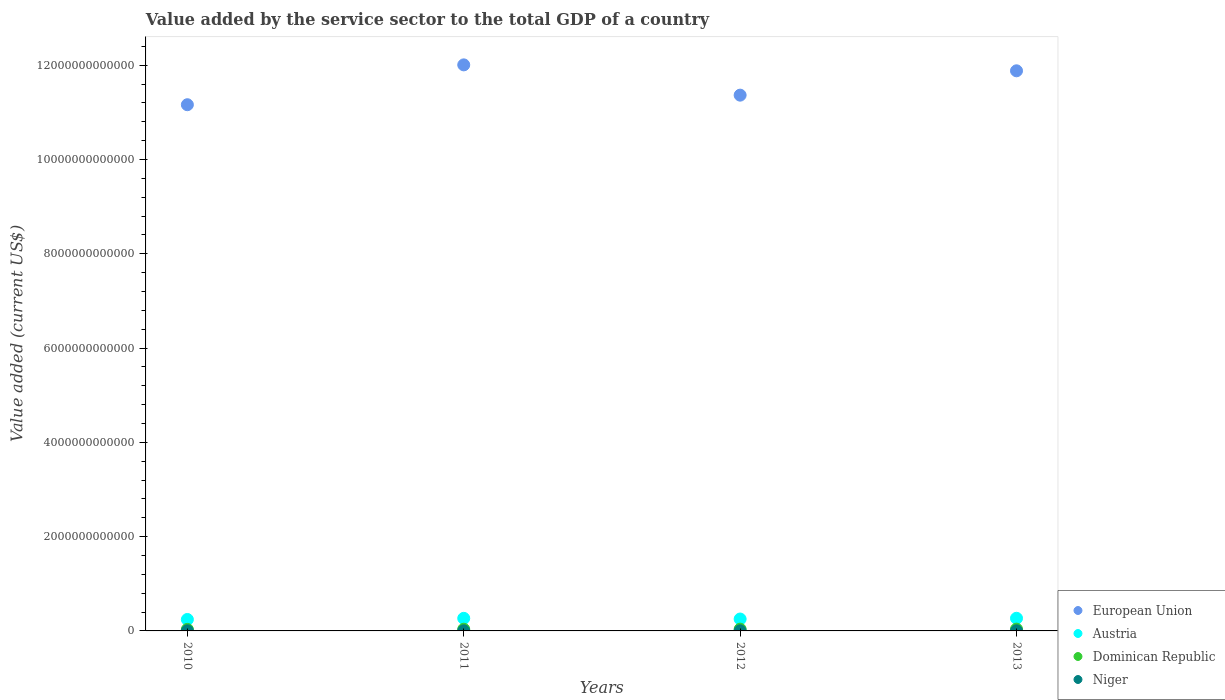How many different coloured dotlines are there?
Your answer should be very brief. 4. What is the value added by the service sector to the total GDP in Niger in 2012?
Your answer should be very brief. 2.84e+09. Across all years, what is the maximum value added by the service sector to the total GDP in Dominican Republic?
Provide a short and direct response. 3.82e+1. Across all years, what is the minimum value added by the service sector to the total GDP in European Union?
Ensure brevity in your answer.  1.12e+13. What is the total value added by the service sector to the total GDP in Dominican Republic in the graph?
Offer a very short reply. 1.44e+11. What is the difference between the value added by the service sector to the total GDP in Dominican Republic in 2011 and that in 2013?
Give a very brief answer. -2.26e+09. What is the difference between the value added by the service sector to the total GDP in European Union in 2012 and the value added by the service sector to the total GDP in Niger in 2010?
Your answer should be very brief. 1.14e+13. What is the average value added by the service sector to the total GDP in Dominican Republic per year?
Your answer should be compact. 3.61e+1. In the year 2010, what is the difference between the value added by the service sector to the total GDP in Austria and value added by the service sector to the total GDP in Dominican Republic?
Ensure brevity in your answer.  2.10e+11. In how many years, is the value added by the service sector to the total GDP in Austria greater than 7200000000000 US$?
Offer a terse response. 0. What is the ratio of the value added by the service sector to the total GDP in Niger in 2010 to that in 2011?
Provide a short and direct response. 0.85. Is the value added by the service sector to the total GDP in Dominican Republic in 2012 less than that in 2013?
Provide a short and direct response. Yes. What is the difference between the highest and the second highest value added by the service sector to the total GDP in European Union?
Give a very brief answer. 1.26e+11. What is the difference between the highest and the lowest value added by the service sector to the total GDP in Dominican Republic?
Ensure brevity in your answer.  5.58e+09. In how many years, is the value added by the service sector to the total GDP in Dominican Republic greater than the average value added by the service sector to the total GDP in Dominican Republic taken over all years?
Give a very brief answer. 2. Is it the case that in every year, the sum of the value added by the service sector to the total GDP in European Union and value added by the service sector to the total GDP in Austria  is greater than the sum of value added by the service sector to the total GDP in Niger and value added by the service sector to the total GDP in Dominican Republic?
Provide a short and direct response. Yes. Does the value added by the service sector to the total GDP in Dominican Republic monotonically increase over the years?
Provide a succinct answer. Yes. How many years are there in the graph?
Your response must be concise. 4. What is the difference between two consecutive major ticks on the Y-axis?
Keep it short and to the point. 2.00e+12. Does the graph contain grids?
Provide a short and direct response. No. Where does the legend appear in the graph?
Give a very brief answer. Bottom right. How are the legend labels stacked?
Your answer should be compact. Vertical. What is the title of the graph?
Provide a short and direct response. Value added by the service sector to the total GDP of a country. What is the label or title of the X-axis?
Your answer should be very brief. Years. What is the label or title of the Y-axis?
Make the answer very short. Value added (current US$). What is the Value added (current US$) of European Union in 2010?
Make the answer very short. 1.12e+13. What is the Value added (current US$) in Austria in 2010?
Provide a short and direct response. 2.43e+11. What is the Value added (current US$) in Dominican Republic in 2010?
Provide a succinct answer. 3.26e+1. What is the Value added (current US$) in Niger in 2010?
Provide a succinct answer. 2.49e+09. What is the Value added (current US$) of European Union in 2011?
Offer a very short reply. 1.20e+13. What is the Value added (current US$) in Austria in 2011?
Offer a very short reply. 2.67e+11. What is the Value added (current US$) in Dominican Republic in 2011?
Keep it short and to the point. 3.59e+1. What is the Value added (current US$) in Niger in 2011?
Ensure brevity in your answer.  2.93e+09. What is the Value added (current US$) of European Union in 2012?
Keep it short and to the point. 1.14e+13. What is the Value added (current US$) of Austria in 2012?
Offer a terse response. 2.52e+11. What is the Value added (current US$) in Dominican Republic in 2012?
Make the answer very short. 3.77e+1. What is the Value added (current US$) of Niger in 2012?
Provide a short and direct response. 2.84e+09. What is the Value added (current US$) in European Union in 2013?
Offer a terse response. 1.19e+13. What is the Value added (current US$) of Austria in 2013?
Your response must be concise. 2.68e+11. What is the Value added (current US$) of Dominican Republic in 2013?
Your response must be concise. 3.82e+1. What is the Value added (current US$) of Niger in 2013?
Provide a short and direct response. 3.25e+09. Across all years, what is the maximum Value added (current US$) in European Union?
Ensure brevity in your answer.  1.20e+13. Across all years, what is the maximum Value added (current US$) in Austria?
Ensure brevity in your answer.  2.68e+11. Across all years, what is the maximum Value added (current US$) of Dominican Republic?
Keep it short and to the point. 3.82e+1. Across all years, what is the maximum Value added (current US$) of Niger?
Your response must be concise. 3.25e+09. Across all years, what is the minimum Value added (current US$) of European Union?
Provide a short and direct response. 1.12e+13. Across all years, what is the minimum Value added (current US$) in Austria?
Offer a very short reply. 2.43e+11. Across all years, what is the minimum Value added (current US$) in Dominican Republic?
Keep it short and to the point. 3.26e+1. Across all years, what is the minimum Value added (current US$) in Niger?
Offer a terse response. 2.49e+09. What is the total Value added (current US$) in European Union in the graph?
Keep it short and to the point. 4.64e+13. What is the total Value added (current US$) in Austria in the graph?
Offer a very short reply. 1.03e+12. What is the total Value added (current US$) of Dominican Republic in the graph?
Ensure brevity in your answer.  1.44e+11. What is the total Value added (current US$) in Niger in the graph?
Offer a terse response. 1.15e+1. What is the difference between the Value added (current US$) in European Union in 2010 and that in 2011?
Keep it short and to the point. -8.45e+11. What is the difference between the Value added (current US$) of Austria in 2010 and that in 2011?
Offer a terse response. -2.41e+1. What is the difference between the Value added (current US$) in Dominican Republic in 2010 and that in 2011?
Make the answer very short. -3.31e+09. What is the difference between the Value added (current US$) of Niger in 2010 and that in 2011?
Provide a succinct answer. -4.40e+08. What is the difference between the Value added (current US$) of European Union in 2010 and that in 2012?
Provide a short and direct response. -2.03e+11. What is the difference between the Value added (current US$) in Austria in 2010 and that in 2012?
Give a very brief answer. -9.58e+09. What is the difference between the Value added (current US$) of Dominican Republic in 2010 and that in 2012?
Ensure brevity in your answer.  -5.04e+09. What is the difference between the Value added (current US$) of Niger in 2010 and that in 2012?
Provide a short and direct response. -3.49e+08. What is the difference between the Value added (current US$) of European Union in 2010 and that in 2013?
Offer a terse response. -7.19e+11. What is the difference between the Value added (current US$) of Austria in 2010 and that in 2013?
Make the answer very short. -2.56e+1. What is the difference between the Value added (current US$) of Dominican Republic in 2010 and that in 2013?
Your answer should be compact. -5.58e+09. What is the difference between the Value added (current US$) of Niger in 2010 and that in 2013?
Offer a very short reply. -7.64e+08. What is the difference between the Value added (current US$) of European Union in 2011 and that in 2012?
Your answer should be compact. 6.42e+11. What is the difference between the Value added (current US$) in Austria in 2011 and that in 2012?
Your answer should be very brief. 1.45e+1. What is the difference between the Value added (current US$) of Dominican Republic in 2011 and that in 2012?
Provide a succinct answer. -1.73e+09. What is the difference between the Value added (current US$) of Niger in 2011 and that in 2012?
Ensure brevity in your answer.  9.05e+07. What is the difference between the Value added (current US$) in European Union in 2011 and that in 2013?
Your response must be concise. 1.26e+11. What is the difference between the Value added (current US$) in Austria in 2011 and that in 2013?
Your response must be concise. -1.50e+09. What is the difference between the Value added (current US$) in Dominican Republic in 2011 and that in 2013?
Give a very brief answer. -2.26e+09. What is the difference between the Value added (current US$) of Niger in 2011 and that in 2013?
Give a very brief answer. -3.25e+08. What is the difference between the Value added (current US$) of European Union in 2012 and that in 2013?
Provide a short and direct response. -5.16e+11. What is the difference between the Value added (current US$) in Austria in 2012 and that in 2013?
Ensure brevity in your answer.  -1.60e+1. What is the difference between the Value added (current US$) of Dominican Republic in 2012 and that in 2013?
Your response must be concise. -5.32e+08. What is the difference between the Value added (current US$) in Niger in 2012 and that in 2013?
Offer a very short reply. -4.15e+08. What is the difference between the Value added (current US$) of European Union in 2010 and the Value added (current US$) of Austria in 2011?
Your answer should be very brief. 1.09e+13. What is the difference between the Value added (current US$) in European Union in 2010 and the Value added (current US$) in Dominican Republic in 2011?
Your answer should be compact. 1.11e+13. What is the difference between the Value added (current US$) of European Union in 2010 and the Value added (current US$) of Niger in 2011?
Provide a succinct answer. 1.12e+13. What is the difference between the Value added (current US$) in Austria in 2010 and the Value added (current US$) in Dominican Republic in 2011?
Your response must be concise. 2.07e+11. What is the difference between the Value added (current US$) of Austria in 2010 and the Value added (current US$) of Niger in 2011?
Make the answer very short. 2.40e+11. What is the difference between the Value added (current US$) of Dominican Republic in 2010 and the Value added (current US$) of Niger in 2011?
Your response must be concise. 2.97e+1. What is the difference between the Value added (current US$) of European Union in 2010 and the Value added (current US$) of Austria in 2012?
Ensure brevity in your answer.  1.09e+13. What is the difference between the Value added (current US$) of European Union in 2010 and the Value added (current US$) of Dominican Republic in 2012?
Give a very brief answer. 1.11e+13. What is the difference between the Value added (current US$) in European Union in 2010 and the Value added (current US$) in Niger in 2012?
Your answer should be compact. 1.12e+13. What is the difference between the Value added (current US$) of Austria in 2010 and the Value added (current US$) of Dominican Republic in 2012?
Offer a very short reply. 2.05e+11. What is the difference between the Value added (current US$) in Austria in 2010 and the Value added (current US$) in Niger in 2012?
Make the answer very short. 2.40e+11. What is the difference between the Value added (current US$) in Dominican Republic in 2010 and the Value added (current US$) in Niger in 2012?
Offer a very short reply. 2.98e+1. What is the difference between the Value added (current US$) in European Union in 2010 and the Value added (current US$) in Austria in 2013?
Offer a terse response. 1.09e+13. What is the difference between the Value added (current US$) of European Union in 2010 and the Value added (current US$) of Dominican Republic in 2013?
Your answer should be very brief. 1.11e+13. What is the difference between the Value added (current US$) of European Union in 2010 and the Value added (current US$) of Niger in 2013?
Your answer should be very brief. 1.12e+13. What is the difference between the Value added (current US$) in Austria in 2010 and the Value added (current US$) in Dominican Republic in 2013?
Your answer should be compact. 2.05e+11. What is the difference between the Value added (current US$) in Austria in 2010 and the Value added (current US$) in Niger in 2013?
Offer a very short reply. 2.40e+11. What is the difference between the Value added (current US$) of Dominican Republic in 2010 and the Value added (current US$) of Niger in 2013?
Your answer should be compact. 2.94e+1. What is the difference between the Value added (current US$) of European Union in 2011 and the Value added (current US$) of Austria in 2012?
Provide a short and direct response. 1.18e+13. What is the difference between the Value added (current US$) of European Union in 2011 and the Value added (current US$) of Dominican Republic in 2012?
Provide a short and direct response. 1.20e+13. What is the difference between the Value added (current US$) of European Union in 2011 and the Value added (current US$) of Niger in 2012?
Keep it short and to the point. 1.20e+13. What is the difference between the Value added (current US$) in Austria in 2011 and the Value added (current US$) in Dominican Republic in 2012?
Offer a very short reply. 2.29e+11. What is the difference between the Value added (current US$) in Austria in 2011 and the Value added (current US$) in Niger in 2012?
Ensure brevity in your answer.  2.64e+11. What is the difference between the Value added (current US$) of Dominican Republic in 2011 and the Value added (current US$) of Niger in 2012?
Ensure brevity in your answer.  3.31e+1. What is the difference between the Value added (current US$) in European Union in 2011 and the Value added (current US$) in Austria in 2013?
Keep it short and to the point. 1.17e+13. What is the difference between the Value added (current US$) of European Union in 2011 and the Value added (current US$) of Dominican Republic in 2013?
Offer a very short reply. 1.20e+13. What is the difference between the Value added (current US$) of European Union in 2011 and the Value added (current US$) of Niger in 2013?
Provide a succinct answer. 1.20e+13. What is the difference between the Value added (current US$) in Austria in 2011 and the Value added (current US$) in Dominican Republic in 2013?
Your response must be concise. 2.29e+11. What is the difference between the Value added (current US$) in Austria in 2011 and the Value added (current US$) in Niger in 2013?
Offer a very short reply. 2.64e+11. What is the difference between the Value added (current US$) in Dominican Republic in 2011 and the Value added (current US$) in Niger in 2013?
Your answer should be very brief. 3.27e+1. What is the difference between the Value added (current US$) in European Union in 2012 and the Value added (current US$) in Austria in 2013?
Your response must be concise. 1.11e+13. What is the difference between the Value added (current US$) of European Union in 2012 and the Value added (current US$) of Dominican Republic in 2013?
Ensure brevity in your answer.  1.13e+13. What is the difference between the Value added (current US$) of European Union in 2012 and the Value added (current US$) of Niger in 2013?
Keep it short and to the point. 1.14e+13. What is the difference between the Value added (current US$) in Austria in 2012 and the Value added (current US$) in Dominican Republic in 2013?
Provide a succinct answer. 2.14e+11. What is the difference between the Value added (current US$) of Austria in 2012 and the Value added (current US$) of Niger in 2013?
Your answer should be very brief. 2.49e+11. What is the difference between the Value added (current US$) in Dominican Republic in 2012 and the Value added (current US$) in Niger in 2013?
Offer a terse response. 3.44e+1. What is the average Value added (current US$) of European Union per year?
Make the answer very short. 1.16e+13. What is the average Value added (current US$) in Austria per year?
Keep it short and to the point. 2.58e+11. What is the average Value added (current US$) of Dominican Republic per year?
Your answer should be very brief. 3.61e+1. What is the average Value added (current US$) in Niger per year?
Keep it short and to the point. 2.87e+09. In the year 2010, what is the difference between the Value added (current US$) of European Union and Value added (current US$) of Austria?
Offer a terse response. 1.09e+13. In the year 2010, what is the difference between the Value added (current US$) in European Union and Value added (current US$) in Dominican Republic?
Your answer should be very brief. 1.11e+13. In the year 2010, what is the difference between the Value added (current US$) in European Union and Value added (current US$) in Niger?
Your answer should be compact. 1.12e+13. In the year 2010, what is the difference between the Value added (current US$) in Austria and Value added (current US$) in Dominican Republic?
Your answer should be very brief. 2.10e+11. In the year 2010, what is the difference between the Value added (current US$) of Austria and Value added (current US$) of Niger?
Keep it short and to the point. 2.40e+11. In the year 2010, what is the difference between the Value added (current US$) of Dominican Republic and Value added (current US$) of Niger?
Make the answer very short. 3.01e+1. In the year 2011, what is the difference between the Value added (current US$) in European Union and Value added (current US$) in Austria?
Your response must be concise. 1.17e+13. In the year 2011, what is the difference between the Value added (current US$) of European Union and Value added (current US$) of Dominican Republic?
Make the answer very short. 1.20e+13. In the year 2011, what is the difference between the Value added (current US$) of European Union and Value added (current US$) of Niger?
Make the answer very short. 1.20e+13. In the year 2011, what is the difference between the Value added (current US$) of Austria and Value added (current US$) of Dominican Republic?
Offer a very short reply. 2.31e+11. In the year 2011, what is the difference between the Value added (current US$) of Austria and Value added (current US$) of Niger?
Your answer should be very brief. 2.64e+11. In the year 2011, what is the difference between the Value added (current US$) of Dominican Republic and Value added (current US$) of Niger?
Your response must be concise. 3.30e+1. In the year 2012, what is the difference between the Value added (current US$) of European Union and Value added (current US$) of Austria?
Ensure brevity in your answer.  1.11e+13. In the year 2012, what is the difference between the Value added (current US$) of European Union and Value added (current US$) of Dominican Republic?
Your response must be concise. 1.13e+13. In the year 2012, what is the difference between the Value added (current US$) of European Union and Value added (current US$) of Niger?
Your answer should be very brief. 1.14e+13. In the year 2012, what is the difference between the Value added (current US$) of Austria and Value added (current US$) of Dominican Republic?
Make the answer very short. 2.15e+11. In the year 2012, what is the difference between the Value added (current US$) of Austria and Value added (current US$) of Niger?
Your response must be concise. 2.50e+11. In the year 2012, what is the difference between the Value added (current US$) of Dominican Republic and Value added (current US$) of Niger?
Make the answer very short. 3.48e+1. In the year 2013, what is the difference between the Value added (current US$) of European Union and Value added (current US$) of Austria?
Offer a terse response. 1.16e+13. In the year 2013, what is the difference between the Value added (current US$) in European Union and Value added (current US$) in Dominican Republic?
Your response must be concise. 1.18e+13. In the year 2013, what is the difference between the Value added (current US$) of European Union and Value added (current US$) of Niger?
Offer a terse response. 1.19e+13. In the year 2013, what is the difference between the Value added (current US$) of Austria and Value added (current US$) of Dominican Republic?
Ensure brevity in your answer.  2.30e+11. In the year 2013, what is the difference between the Value added (current US$) of Austria and Value added (current US$) of Niger?
Ensure brevity in your answer.  2.65e+11. In the year 2013, what is the difference between the Value added (current US$) in Dominican Republic and Value added (current US$) in Niger?
Your answer should be compact. 3.49e+1. What is the ratio of the Value added (current US$) of European Union in 2010 to that in 2011?
Your answer should be very brief. 0.93. What is the ratio of the Value added (current US$) in Austria in 2010 to that in 2011?
Your answer should be compact. 0.91. What is the ratio of the Value added (current US$) in Dominican Republic in 2010 to that in 2011?
Your response must be concise. 0.91. What is the ratio of the Value added (current US$) of Niger in 2010 to that in 2011?
Make the answer very short. 0.85. What is the ratio of the Value added (current US$) in European Union in 2010 to that in 2012?
Offer a terse response. 0.98. What is the ratio of the Value added (current US$) of Austria in 2010 to that in 2012?
Keep it short and to the point. 0.96. What is the ratio of the Value added (current US$) in Dominican Republic in 2010 to that in 2012?
Provide a succinct answer. 0.87. What is the ratio of the Value added (current US$) of Niger in 2010 to that in 2012?
Make the answer very short. 0.88. What is the ratio of the Value added (current US$) of European Union in 2010 to that in 2013?
Your answer should be compact. 0.94. What is the ratio of the Value added (current US$) of Austria in 2010 to that in 2013?
Your response must be concise. 0.9. What is the ratio of the Value added (current US$) of Dominican Republic in 2010 to that in 2013?
Your answer should be very brief. 0.85. What is the ratio of the Value added (current US$) in Niger in 2010 to that in 2013?
Keep it short and to the point. 0.76. What is the ratio of the Value added (current US$) of European Union in 2011 to that in 2012?
Offer a very short reply. 1.06. What is the ratio of the Value added (current US$) of Austria in 2011 to that in 2012?
Ensure brevity in your answer.  1.06. What is the ratio of the Value added (current US$) of Dominican Republic in 2011 to that in 2012?
Give a very brief answer. 0.95. What is the ratio of the Value added (current US$) of Niger in 2011 to that in 2012?
Keep it short and to the point. 1.03. What is the ratio of the Value added (current US$) in European Union in 2011 to that in 2013?
Your answer should be compact. 1.01. What is the ratio of the Value added (current US$) in Dominican Republic in 2011 to that in 2013?
Make the answer very short. 0.94. What is the ratio of the Value added (current US$) of Niger in 2011 to that in 2013?
Ensure brevity in your answer.  0.9. What is the ratio of the Value added (current US$) of European Union in 2012 to that in 2013?
Your answer should be compact. 0.96. What is the ratio of the Value added (current US$) in Austria in 2012 to that in 2013?
Offer a very short reply. 0.94. What is the ratio of the Value added (current US$) in Dominican Republic in 2012 to that in 2013?
Give a very brief answer. 0.99. What is the ratio of the Value added (current US$) of Niger in 2012 to that in 2013?
Your answer should be very brief. 0.87. What is the difference between the highest and the second highest Value added (current US$) of European Union?
Provide a short and direct response. 1.26e+11. What is the difference between the highest and the second highest Value added (current US$) of Austria?
Your answer should be very brief. 1.50e+09. What is the difference between the highest and the second highest Value added (current US$) in Dominican Republic?
Provide a short and direct response. 5.32e+08. What is the difference between the highest and the second highest Value added (current US$) of Niger?
Give a very brief answer. 3.25e+08. What is the difference between the highest and the lowest Value added (current US$) in European Union?
Keep it short and to the point. 8.45e+11. What is the difference between the highest and the lowest Value added (current US$) of Austria?
Offer a terse response. 2.56e+1. What is the difference between the highest and the lowest Value added (current US$) of Dominican Republic?
Your answer should be compact. 5.58e+09. What is the difference between the highest and the lowest Value added (current US$) of Niger?
Provide a succinct answer. 7.64e+08. 